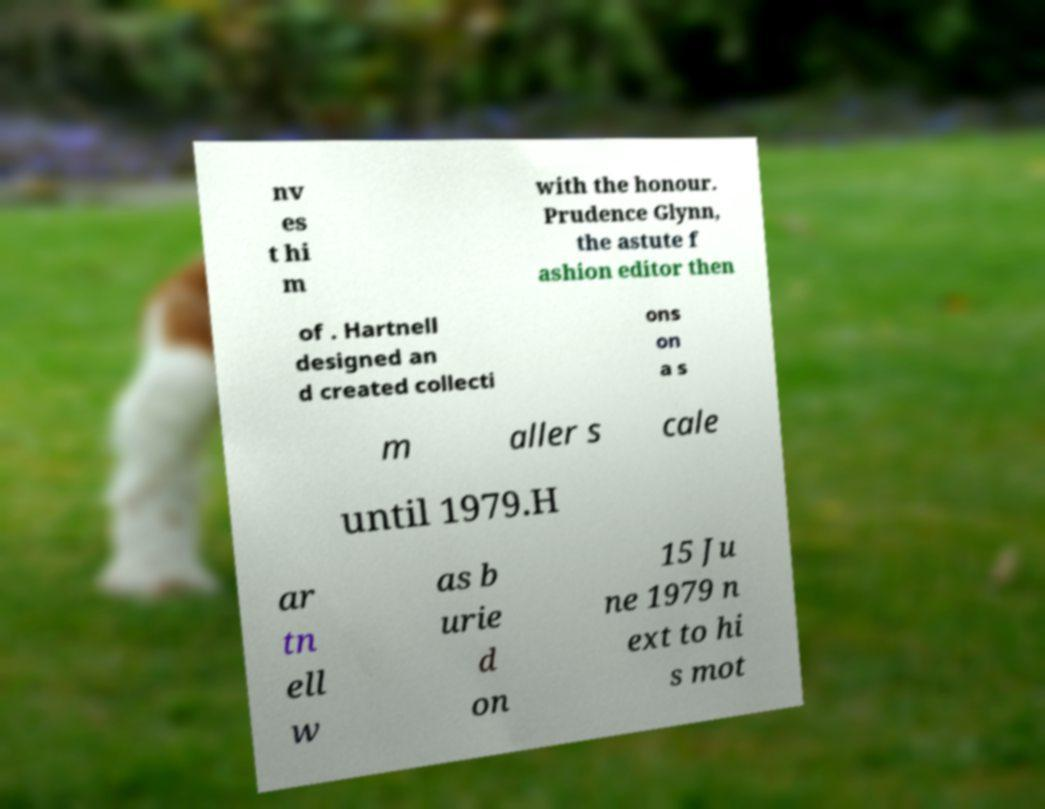Could you extract and type out the text from this image? nv es t hi m with the honour. Prudence Glynn, the astute f ashion editor then of . Hartnell designed an d created collecti ons on a s m aller s cale until 1979.H ar tn ell w as b urie d on 15 Ju ne 1979 n ext to hi s mot 